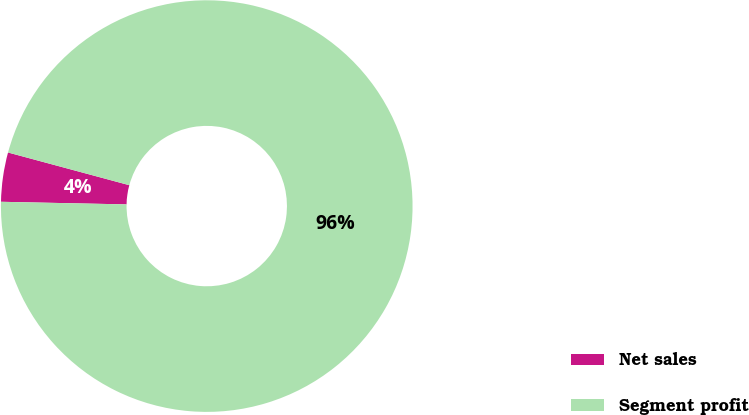<chart> <loc_0><loc_0><loc_500><loc_500><pie_chart><fcel>Net sales<fcel>Segment profit<nl><fcel>3.86%<fcel>96.14%<nl></chart> 